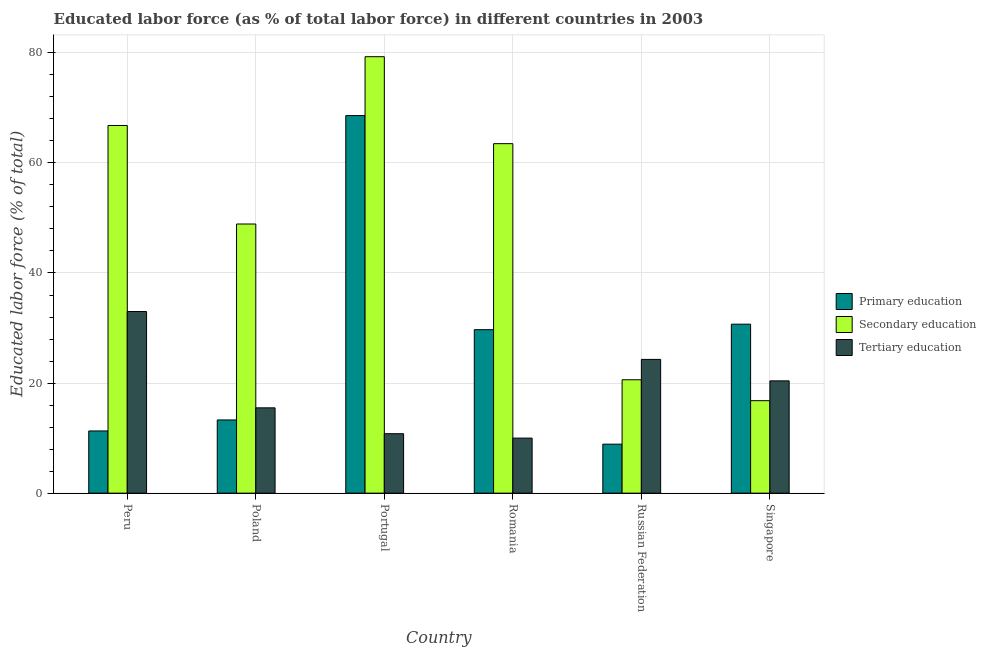Are the number of bars on each tick of the X-axis equal?
Your response must be concise. Yes. How many bars are there on the 6th tick from the left?
Give a very brief answer. 3. How many bars are there on the 3rd tick from the right?
Offer a very short reply. 3. What is the label of the 6th group of bars from the left?
Ensure brevity in your answer.  Singapore. In how many cases, is the number of bars for a given country not equal to the number of legend labels?
Your answer should be compact. 0. What is the percentage of labor force who received tertiary education in Portugal?
Your answer should be very brief. 10.8. Across all countries, what is the minimum percentage of labor force who received secondary education?
Your response must be concise. 16.8. In which country was the percentage of labor force who received primary education minimum?
Give a very brief answer. Russian Federation. What is the total percentage of labor force who received secondary education in the graph?
Provide a short and direct response. 295.9. What is the difference between the percentage of labor force who received secondary education in Peru and that in Poland?
Offer a terse response. 17.9. What is the difference between the percentage of labor force who received secondary education in Peru and the percentage of labor force who received primary education in Romania?
Your answer should be compact. 37.1. What is the average percentage of labor force who received tertiary education per country?
Give a very brief answer. 19. What is the difference between the percentage of labor force who received secondary education and percentage of labor force who received primary education in Romania?
Provide a succinct answer. 33.8. In how many countries, is the percentage of labor force who received secondary education greater than 48 %?
Provide a succinct answer. 4. What is the ratio of the percentage of labor force who received tertiary education in Portugal to that in Romania?
Keep it short and to the point. 1.08. What is the difference between the highest and the second highest percentage of labor force who received primary education?
Your answer should be very brief. 37.9. In how many countries, is the percentage of labor force who received secondary education greater than the average percentage of labor force who received secondary education taken over all countries?
Your answer should be compact. 3. What does the 1st bar from the left in Singapore represents?
Offer a terse response. Primary education. What does the 1st bar from the right in Poland represents?
Give a very brief answer. Tertiary education. How many bars are there?
Give a very brief answer. 18. Are all the bars in the graph horizontal?
Offer a terse response. No. How many countries are there in the graph?
Your answer should be very brief. 6. Does the graph contain grids?
Provide a succinct answer. Yes. How many legend labels are there?
Ensure brevity in your answer.  3. What is the title of the graph?
Keep it short and to the point. Educated labor force (as % of total labor force) in different countries in 2003. What is the label or title of the X-axis?
Provide a succinct answer. Country. What is the label or title of the Y-axis?
Make the answer very short. Educated labor force (% of total). What is the Educated labor force (% of total) of Primary education in Peru?
Provide a succinct answer. 11.3. What is the Educated labor force (% of total) of Secondary education in Peru?
Your answer should be very brief. 66.8. What is the Educated labor force (% of total) in Tertiary education in Peru?
Ensure brevity in your answer.  33. What is the Educated labor force (% of total) of Primary education in Poland?
Make the answer very short. 13.3. What is the Educated labor force (% of total) of Secondary education in Poland?
Make the answer very short. 48.9. What is the Educated labor force (% of total) in Tertiary education in Poland?
Give a very brief answer. 15.5. What is the Educated labor force (% of total) of Primary education in Portugal?
Give a very brief answer. 68.6. What is the Educated labor force (% of total) of Secondary education in Portugal?
Your answer should be compact. 79.3. What is the Educated labor force (% of total) in Tertiary education in Portugal?
Ensure brevity in your answer.  10.8. What is the Educated labor force (% of total) in Primary education in Romania?
Ensure brevity in your answer.  29.7. What is the Educated labor force (% of total) of Secondary education in Romania?
Provide a short and direct response. 63.5. What is the Educated labor force (% of total) of Primary education in Russian Federation?
Make the answer very short. 8.9. What is the Educated labor force (% of total) in Secondary education in Russian Federation?
Your response must be concise. 20.6. What is the Educated labor force (% of total) of Tertiary education in Russian Federation?
Make the answer very short. 24.3. What is the Educated labor force (% of total) of Primary education in Singapore?
Give a very brief answer. 30.7. What is the Educated labor force (% of total) in Secondary education in Singapore?
Keep it short and to the point. 16.8. What is the Educated labor force (% of total) in Tertiary education in Singapore?
Offer a very short reply. 20.4. Across all countries, what is the maximum Educated labor force (% of total) in Primary education?
Offer a very short reply. 68.6. Across all countries, what is the maximum Educated labor force (% of total) in Secondary education?
Give a very brief answer. 79.3. Across all countries, what is the minimum Educated labor force (% of total) of Primary education?
Provide a short and direct response. 8.9. Across all countries, what is the minimum Educated labor force (% of total) in Secondary education?
Offer a very short reply. 16.8. What is the total Educated labor force (% of total) of Primary education in the graph?
Provide a succinct answer. 162.5. What is the total Educated labor force (% of total) in Secondary education in the graph?
Ensure brevity in your answer.  295.9. What is the total Educated labor force (% of total) of Tertiary education in the graph?
Provide a succinct answer. 114. What is the difference between the Educated labor force (% of total) in Primary education in Peru and that in Poland?
Give a very brief answer. -2. What is the difference between the Educated labor force (% of total) in Secondary education in Peru and that in Poland?
Give a very brief answer. 17.9. What is the difference between the Educated labor force (% of total) of Tertiary education in Peru and that in Poland?
Your answer should be compact. 17.5. What is the difference between the Educated labor force (% of total) of Primary education in Peru and that in Portugal?
Provide a succinct answer. -57.3. What is the difference between the Educated labor force (% of total) in Secondary education in Peru and that in Portugal?
Keep it short and to the point. -12.5. What is the difference between the Educated labor force (% of total) in Tertiary education in Peru and that in Portugal?
Your answer should be compact. 22.2. What is the difference between the Educated labor force (% of total) of Primary education in Peru and that in Romania?
Keep it short and to the point. -18.4. What is the difference between the Educated labor force (% of total) in Tertiary education in Peru and that in Romania?
Keep it short and to the point. 23. What is the difference between the Educated labor force (% of total) in Secondary education in Peru and that in Russian Federation?
Your answer should be compact. 46.2. What is the difference between the Educated labor force (% of total) in Primary education in Peru and that in Singapore?
Your answer should be very brief. -19.4. What is the difference between the Educated labor force (% of total) of Primary education in Poland and that in Portugal?
Provide a succinct answer. -55.3. What is the difference between the Educated labor force (% of total) in Secondary education in Poland and that in Portugal?
Keep it short and to the point. -30.4. What is the difference between the Educated labor force (% of total) of Primary education in Poland and that in Romania?
Offer a terse response. -16.4. What is the difference between the Educated labor force (% of total) in Secondary education in Poland and that in Romania?
Provide a short and direct response. -14.6. What is the difference between the Educated labor force (% of total) in Secondary education in Poland and that in Russian Federation?
Your answer should be compact. 28.3. What is the difference between the Educated labor force (% of total) in Primary education in Poland and that in Singapore?
Ensure brevity in your answer.  -17.4. What is the difference between the Educated labor force (% of total) in Secondary education in Poland and that in Singapore?
Your answer should be compact. 32.1. What is the difference between the Educated labor force (% of total) of Tertiary education in Poland and that in Singapore?
Keep it short and to the point. -4.9. What is the difference between the Educated labor force (% of total) of Primary education in Portugal and that in Romania?
Keep it short and to the point. 38.9. What is the difference between the Educated labor force (% of total) in Secondary education in Portugal and that in Romania?
Provide a succinct answer. 15.8. What is the difference between the Educated labor force (% of total) in Primary education in Portugal and that in Russian Federation?
Keep it short and to the point. 59.7. What is the difference between the Educated labor force (% of total) of Secondary education in Portugal and that in Russian Federation?
Ensure brevity in your answer.  58.7. What is the difference between the Educated labor force (% of total) in Primary education in Portugal and that in Singapore?
Offer a terse response. 37.9. What is the difference between the Educated labor force (% of total) in Secondary education in Portugal and that in Singapore?
Make the answer very short. 62.5. What is the difference between the Educated labor force (% of total) in Primary education in Romania and that in Russian Federation?
Your answer should be very brief. 20.8. What is the difference between the Educated labor force (% of total) in Secondary education in Romania and that in Russian Federation?
Make the answer very short. 42.9. What is the difference between the Educated labor force (% of total) of Tertiary education in Romania and that in Russian Federation?
Your answer should be very brief. -14.3. What is the difference between the Educated labor force (% of total) of Primary education in Romania and that in Singapore?
Offer a terse response. -1. What is the difference between the Educated labor force (% of total) of Secondary education in Romania and that in Singapore?
Offer a terse response. 46.7. What is the difference between the Educated labor force (% of total) in Primary education in Russian Federation and that in Singapore?
Your answer should be compact. -21.8. What is the difference between the Educated labor force (% of total) in Secondary education in Russian Federation and that in Singapore?
Your answer should be very brief. 3.8. What is the difference between the Educated labor force (% of total) in Tertiary education in Russian Federation and that in Singapore?
Your response must be concise. 3.9. What is the difference between the Educated labor force (% of total) of Primary education in Peru and the Educated labor force (% of total) of Secondary education in Poland?
Your answer should be very brief. -37.6. What is the difference between the Educated labor force (% of total) in Primary education in Peru and the Educated labor force (% of total) in Tertiary education in Poland?
Your answer should be compact. -4.2. What is the difference between the Educated labor force (% of total) in Secondary education in Peru and the Educated labor force (% of total) in Tertiary education in Poland?
Offer a terse response. 51.3. What is the difference between the Educated labor force (% of total) of Primary education in Peru and the Educated labor force (% of total) of Secondary education in Portugal?
Offer a terse response. -68. What is the difference between the Educated labor force (% of total) in Primary education in Peru and the Educated labor force (% of total) in Secondary education in Romania?
Ensure brevity in your answer.  -52.2. What is the difference between the Educated labor force (% of total) of Secondary education in Peru and the Educated labor force (% of total) of Tertiary education in Romania?
Provide a succinct answer. 56.8. What is the difference between the Educated labor force (% of total) in Primary education in Peru and the Educated labor force (% of total) in Tertiary education in Russian Federation?
Offer a very short reply. -13. What is the difference between the Educated labor force (% of total) of Secondary education in Peru and the Educated labor force (% of total) of Tertiary education in Russian Federation?
Offer a terse response. 42.5. What is the difference between the Educated labor force (% of total) in Primary education in Peru and the Educated labor force (% of total) in Tertiary education in Singapore?
Give a very brief answer. -9.1. What is the difference between the Educated labor force (% of total) of Secondary education in Peru and the Educated labor force (% of total) of Tertiary education in Singapore?
Ensure brevity in your answer.  46.4. What is the difference between the Educated labor force (% of total) of Primary education in Poland and the Educated labor force (% of total) of Secondary education in Portugal?
Your answer should be compact. -66. What is the difference between the Educated labor force (% of total) in Primary education in Poland and the Educated labor force (% of total) in Tertiary education in Portugal?
Make the answer very short. 2.5. What is the difference between the Educated labor force (% of total) in Secondary education in Poland and the Educated labor force (% of total) in Tertiary education in Portugal?
Provide a short and direct response. 38.1. What is the difference between the Educated labor force (% of total) of Primary education in Poland and the Educated labor force (% of total) of Secondary education in Romania?
Provide a short and direct response. -50.2. What is the difference between the Educated labor force (% of total) of Secondary education in Poland and the Educated labor force (% of total) of Tertiary education in Romania?
Ensure brevity in your answer.  38.9. What is the difference between the Educated labor force (% of total) in Secondary education in Poland and the Educated labor force (% of total) in Tertiary education in Russian Federation?
Offer a very short reply. 24.6. What is the difference between the Educated labor force (% of total) in Secondary education in Poland and the Educated labor force (% of total) in Tertiary education in Singapore?
Make the answer very short. 28.5. What is the difference between the Educated labor force (% of total) in Primary education in Portugal and the Educated labor force (% of total) in Secondary education in Romania?
Keep it short and to the point. 5.1. What is the difference between the Educated labor force (% of total) in Primary education in Portugal and the Educated labor force (% of total) in Tertiary education in Romania?
Your answer should be compact. 58.6. What is the difference between the Educated labor force (% of total) in Secondary education in Portugal and the Educated labor force (% of total) in Tertiary education in Romania?
Your response must be concise. 69.3. What is the difference between the Educated labor force (% of total) of Primary education in Portugal and the Educated labor force (% of total) of Tertiary education in Russian Federation?
Offer a very short reply. 44.3. What is the difference between the Educated labor force (% of total) of Secondary education in Portugal and the Educated labor force (% of total) of Tertiary education in Russian Federation?
Keep it short and to the point. 55. What is the difference between the Educated labor force (% of total) in Primary education in Portugal and the Educated labor force (% of total) in Secondary education in Singapore?
Your answer should be compact. 51.8. What is the difference between the Educated labor force (% of total) of Primary education in Portugal and the Educated labor force (% of total) of Tertiary education in Singapore?
Provide a short and direct response. 48.2. What is the difference between the Educated labor force (% of total) of Secondary education in Portugal and the Educated labor force (% of total) of Tertiary education in Singapore?
Offer a very short reply. 58.9. What is the difference between the Educated labor force (% of total) in Primary education in Romania and the Educated labor force (% of total) in Secondary education in Russian Federation?
Your response must be concise. 9.1. What is the difference between the Educated labor force (% of total) in Secondary education in Romania and the Educated labor force (% of total) in Tertiary education in Russian Federation?
Your answer should be compact. 39.2. What is the difference between the Educated labor force (% of total) of Primary education in Romania and the Educated labor force (% of total) of Secondary education in Singapore?
Provide a short and direct response. 12.9. What is the difference between the Educated labor force (% of total) in Secondary education in Romania and the Educated labor force (% of total) in Tertiary education in Singapore?
Provide a short and direct response. 43.1. What is the difference between the Educated labor force (% of total) in Primary education in Russian Federation and the Educated labor force (% of total) in Tertiary education in Singapore?
Ensure brevity in your answer.  -11.5. What is the average Educated labor force (% of total) in Primary education per country?
Provide a succinct answer. 27.08. What is the average Educated labor force (% of total) in Secondary education per country?
Make the answer very short. 49.32. What is the difference between the Educated labor force (% of total) in Primary education and Educated labor force (% of total) in Secondary education in Peru?
Give a very brief answer. -55.5. What is the difference between the Educated labor force (% of total) of Primary education and Educated labor force (% of total) of Tertiary education in Peru?
Keep it short and to the point. -21.7. What is the difference between the Educated labor force (% of total) of Secondary education and Educated labor force (% of total) of Tertiary education in Peru?
Offer a very short reply. 33.8. What is the difference between the Educated labor force (% of total) of Primary education and Educated labor force (% of total) of Secondary education in Poland?
Offer a very short reply. -35.6. What is the difference between the Educated labor force (% of total) of Primary education and Educated labor force (% of total) of Tertiary education in Poland?
Make the answer very short. -2.2. What is the difference between the Educated labor force (% of total) of Secondary education and Educated labor force (% of total) of Tertiary education in Poland?
Keep it short and to the point. 33.4. What is the difference between the Educated labor force (% of total) in Primary education and Educated labor force (% of total) in Tertiary education in Portugal?
Offer a very short reply. 57.8. What is the difference between the Educated labor force (% of total) in Secondary education and Educated labor force (% of total) in Tertiary education in Portugal?
Provide a short and direct response. 68.5. What is the difference between the Educated labor force (% of total) of Primary education and Educated labor force (% of total) of Secondary education in Romania?
Keep it short and to the point. -33.8. What is the difference between the Educated labor force (% of total) in Secondary education and Educated labor force (% of total) in Tertiary education in Romania?
Offer a terse response. 53.5. What is the difference between the Educated labor force (% of total) in Primary education and Educated labor force (% of total) in Secondary education in Russian Federation?
Ensure brevity in your answer.  -11.7. What is the difference between the Educated labor force (% of total) of Primary education and Educated labor force (% of total) of Tertiary education in Russian Federation?
Your answer should be compact. -15.4. What is the difference between the Educated labor force (% of total) of Secondary education and Educated labor force (% of total) of Tertiary education in Russian Federation?
Offer a terse response. -3.7. What is the difference between the Educated labor force (% of total) of Primary education and Educated labor force (% of total) of Secondary education in Singapore?
Your answer should be compact. 13.9. What is the difference between the Educated labor force (% of total) in Primary education and Educated labor force (% of total) in Tertiary education in Singapore?
Keep it short and to the point. 10.3. What is the difference between the Educated labor force (% of total) in Secondary education and Educated labor force (% of total) in Tertiary education in Singapore?
Provide a succinct answer. -3.6. What is the ratio of the Educated labor force (% of total) of Primary education in Peru to that in Poland?
Keep it short and to the point. 0.85. What is the ratio of the Educated labor force (% of total) of Secondary education in Peru to that in Poland?
Your answer should be compact. 1.37. What is the ratio of the Educated labor force (% of total) of Tertiary education in Peru to that in Poland?
Provide a short and direct response. 2.13. What is the ratio of the Educated labor force (% of total) of Primary education in Peru to that in Portugal?
Keep it short and to the point. 0.16. What is the ratio of the Educated labor force (% of total) in Secondary education in Peru to that in Portugal?
Provide a short and direct response. 0.84. What is the ratio of the Educated labor force (% of total) in Tertiary education in Peru to that in Portugal?
Offer a terse response. 3.06. What is the ratio of the Educated labor force (% of total) in Primary education in Peru to that in Romania?
Your answer should be very brief. 0.38. What is the ratio of the Educated labor force (% of total) in Secondary education in Peru to that in Romania?
Offer a very short reply. 1.05. What is the ratio of the Educated labor force (% of total) of Tertiary education in Peru to that in Romania?
Provide a short and direct response. 3.3. What is the ratio of the Educated labor force (% of total) in Primary education in Peru to that in Russian Federation?
Your response must be concise. 1.27. What is the ratio of the Educated labor force (% of total) of Secondary education in Peru to that in Russian Federation?
Ensure brevity in your answer.  3.24. What is the ratio of the Educated labor force (% of total) of Tertiary education in Peru to that in Russian Federation?
Your response must be concise. 1.36. What is the ratio of the Educated labor force (% of total) in Primary education in Peru to that in Singapore?
Offer a terse response. 0.37. What is the ratio of the Educated labor force (% of total) in Secondary education in Peru to that in Singapore?
Offer a terse response. 3.98. What is the ratio of the Educated labor force (% of total) in Tertiary education in Peru to that in Singapore?
Make the answer very short. 1.62. What is the ratio of the Educated labor force (% of total) of Primary education in Poland to that in Portugal?
Offer a terse response. 0.19. What is the ratio of the Educated labor force (% of total) of Secondary education in Poland to that in Portugal?
Offer a very short reply. 0.62. What is the ratio of the Educated labor force (% of total) in Tertiary education in Poland to that in Portugal?
Provide a succinct answer. 1.44. What is the ratio of the Educated labor force (% of total) in Primary education in Poland to that in Romania?
Ensure brevity in your answer.  0.45. What is the ratio of the Educated labor force (% of total) in Secondary education in Poland to that in Romania?
Ensure brevity in your answer.  0.77. What is the ratio of the Educated labor force (% of total) in Tertiary education in Poland to that in Romania?
Your answer should be very brief. 1.55. What is the ratio of the Educated labor force (% of total) of Primary education in Poland to that in Russian Federation?
Offer a terse response. 1.49. What is the ratio of the Educated labor force (% of total) of Secondary education in Poland to that in Russian Federation?
Keep it short and to the point. 2.37. What is the ratio of the Educated labor force (% of total) in Tertiary education in Poland to that in Russian Federation?
Keep it short and to the point. 0.64. What is the ratio of the Educated labor force (% of total) of Primary education in Poland to that in Singapore?
Offer a terse response. 0.43. What is the ratio of the Educated labor force (% of total) in Secondary education in Poland to that in Singapore?
Make the answer very short. 2.91. What is the ratio of the Educated labor force (% of total) in Tertiary education in Poland to that in Singapore?
Provide a succinct answer. 0.76. What is the ratio of the Educated labor force (% of total) in Primary education in Portugal to that in Romania?
Your answer should be very brief. 2.31. What is the ratio of the Educated labor force (% of total) of Secondary education in Portugal to that in Romania?
Your response must be concise. 1.25. What is the ratio of the Educated labor force (% of total) in Tertiary education in Portugal to that in Romania?
Your answer should be compact. 1.08. What is the ratio of the Educated labor force (% of total) of Primary education in Portugal to that in Russian Federation?
Your answer should be compact. 7.71. What is the ratio of the Educated labor force (% of total) in Secondary education in Portugal to that in Russian Federation?
Give a very brief answer. 3.85. What is the ratio of the Educated labor force (% of total) of Tertiary education in Portugal to that in Russian Federation?
Offer a very short reply. 0.44. What is the ratio of the Educated labor force (% of total) in Primary education in Portugal to that in Singapore?
Keep it short and to the point. 2.23. What is the ratio of the Educated labor force (% of total) in Secondary education in Portugal to that in Singapore?
Your answer should be compact. 4.72. What is the ratio of the Educated labor force (% of total) of Tertiary education in Portugal to that in Singapore?
Provide a succinct answer. 0.53. What is the ratio of the Educated labor force (% of total) in Primary education in Romania to that in Russian Federation?
Provide a short and direct response. 3.34. What is the ratio of the Educated labor force (% of total) in Secondary education in Romania to that in Russian Federation?
Keep it short and to the point. 3.08. What is the ratio of the Educated labor force (% of total) in Tertiary education in Romania to that in Russian Federation?
Ensure brevity in your answer.  0.41. What is the ratio of the Educated labor force (% of total) in Primary education in Romania to that in Singapore?
Provide a succinct answer. 0.97. What is the ratio of the Educated labor force (% of total) of Secondary education in Romania to that in Singapore?
Ensure brevity in your answer.  3.78. What is the ratio of the Educated labor force (% of total) in Tertiary education in Romania to that in Singapore?
Make the answer very short. 0.49. What is the ratio of the Educated labor force (% of total) of Primary education in Russian Federation to that in Singapore?
Offer a very short reply. 0.29. What is the ratio of the Educated labor force (% of total) in Secondary education in Russian Federation to that in Singapore?
Offer a very short reply. 1.23. What is the ratio of the Educated labor force (% of total) of Tertiary education in Russian Federation to that in Singapore?
Give a very brief answer. 1.19. What is the difference between the highest and the second highest Educated labor force (% of total) in Primary education?
Offer a terse response. 37.9. What is the difference between the highest and the lowest Educated labor force (% of total) of Primary education?
Ensure brevity in your answer.  59.7. What is the difference between the highest and the lowest Educated labor force (% of total) of Secondary education?
Make the answer very short. 62.5. What is the difference between the highest and the lowest Educated labor force (% of total) in Tertiary education?
Provide a short and direct response. 23. 